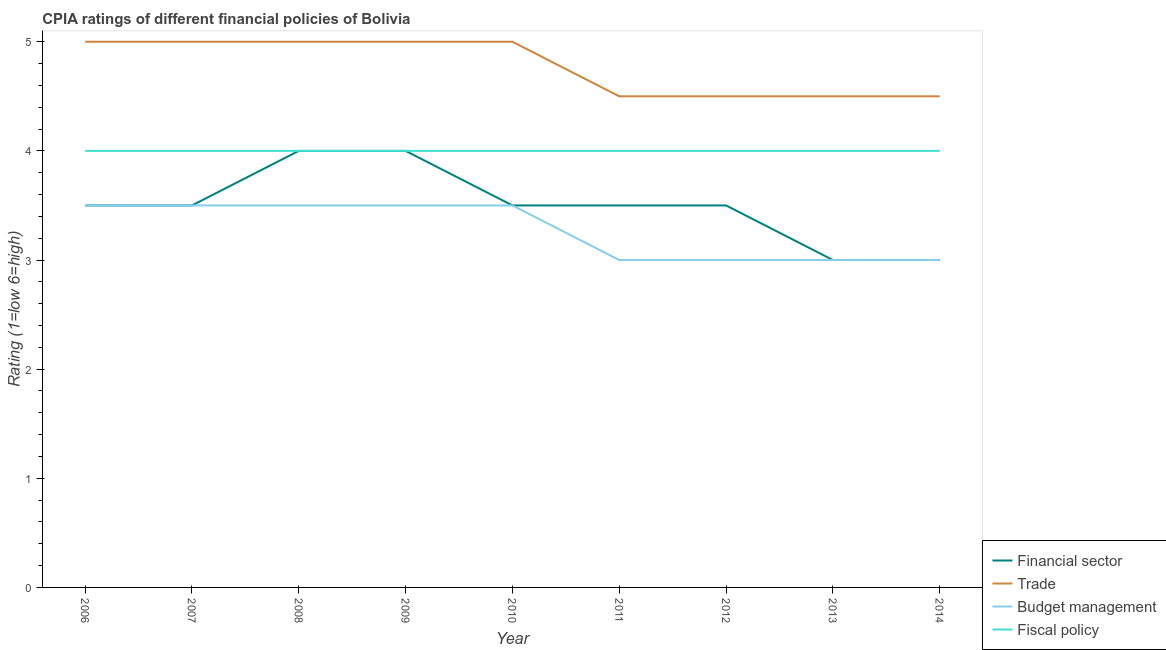How many different coloured lines are there?
Give a very brief answer. 4. Is the number of lines equal to the number of legend labels?
Keep it short and to the point. Yes. What is the cpia rating of fiscal policy in 2011?
Make the answer very short. 4. Across all years, what is the minimum cpia rating of budget management?
Offer a very short reply. 3. In which year was the cpia rating of budget management minimum?
Keep it short and to the point. 2011. What is the total cpia rating of financial sector in the graph?
Give a very brief answer. 31.5. What is the difference between the cpia rating of budget management in 2008 and that in 2011?
Provide a succinct answer. 0.5. What is the average cpia rating of trade per year?
Ensure brevity in your answer.  4.78. What is the ratio of the cpia rating of financial sector in 2008 to that in 2011?
Your answer should be very brief. 1.14. What is the difference between the highest and the second highest cpia rating of financial sector?
Your answer should be very brief. 0. In how many years, is the cpia rating of budget management greater than the average cpia rating of budget management taken over all years?
Keep it short and to the point. 5. Is the sum of the cpia rating of trade in 2007 and 2008 greater than the maximum cpia rating of financial sector across all years?
Provide a succinct answer. Yes. Is it the case that in every year, the sum of the cpia rating of financial sector and cpia rating of trade is greater than the cpia rating of budget management?
Make the answer very short. Yes. How many lines are there?
Give a very brief answer. 4. How many years are there in the graph?
Make the answer very short. 9. How are the legend labels stacked?
Keep it short and to the point. Vertical. What is the title of the graph?
Your response must be concise. CPIA ratings of different financial policies of Bolivia. Does "Secondary" appear as one of the legend labels in the graph?
Keep it short and to the point. No. What is the Rating (1=low 6=high) of Financial sector in 2007?
Provide a succinct answer. 3.5. What is the Rating (1=low 6=high) in Trade in 2007?
Your answer should be very brief. 5. What is the Rating (1=low 6=high) of Budget management in 2007?
Provide a short and direct response. 3.5. What is the Rating (1=low 6=high) in Fiscal policy in 2007?
Your response must be concise. 4. What is the Rating (1=low 6=high) in Budget management in 2008?
Provide a succinct answer. 3.5. What is the Rating (1=low 6=high) of Fiscal policy in 2008?
Keep it short and to the point. 4. What is the Rating (1=low 6=high) in Financial sector in 2009?
Provide a succinct answer. 4. What is the Rating (1=low 6=high) in Trade in 2009?
Keep it short and to the point. 5. What is the Rating (1=low 6=high) in Financial sector in 2010?
Offer a terse response. 3.5. What is the Rating (1=low 6=high) of Fiscal policy in 2010?
Your response must be concise. 4. What is the Rating (1=low 6=high) of Financial sector in 2011?
Your answer should be very brief. 3.5. What is the Rating (1=low 6=high) of Budget management in 2011?
Your answer should be compact. 3. What is the Rating (1=low 6=high) in Financial sector in 2012?
Provide a succinct answer. 3.5. What is the Rating (1=low 6=high) in Financial sector in 2013?
Your response must be concise. 3. What is the Rating (1=low 6=high) of Budget management in 2013?
Provide a succinct answer. 3. What is the Rating (1=low 6=high) of Trade in 2014?
Your response must be concise. 4.5. What is the Rating (1=low 6=high) in Budget management in 2014?
Your answer should be compact. 3. Across all years, what is the maximum Rating (1=low 6=high) of Financial sector?
Offer a very short reply. 4. Across all years, what is the maximum Rating (1=low 6=high) of Fiscal policy?
Your answer should be very brief. 4. Across all years, what is the minimum Rating (1=low 6=high) of Trade?
Your answer should be very brief. 4.5. Across all years, what is the minimum Rating (1=low 6=high) in Fiscal policy?
Make the answer very short. 4. What is the total Rating (1=low 6=high) of Financial sector in the graph?
Offer a terse response. 31.5. What is the total Rating (1=low 6=high) in Trade in the graph?
Your answer should be compact. 43. What is the total Rating (1=low 6=high) of Budget management in the graph?
Your response must be concise. 29.5. What is the total Rating (1=low 6=high) in Fiscal policy in the graph?
Offer a very short reply. 36. What is the difference between the Rating (1=low 6=high) in Financial sector in 2006 and that in 2007?
Keep it short and to the point. 0. What is the difference between the Rating (1=low 6=high) of Trade in 2006 and that in 2007?
Provide a succinct answer. 0. What is the difference between the Rating (1=low 6=high) in Budget management in 2006 and that in 2007?
Keep it short and to the point. 0. What is the difference between the Rating (1=low 6=high) in Fiscal policy in 2006 and that in 2007?
Offer a terse response. 0. What is the difference between the Rating (1=low 6=high) of Fiscal policy in 2006 and that in 2008?
Provide a short and direct response. 0. What is the difference between the Rating (1=low 6=high) of Trade in 2006 and that in 2009?
Offer a very short reply. 0. What is the difference between the Rating (1=low 6=high) of Budget management in 2006 and that in 2010?
Offer a terse response. 0. What is the difference between the Rating (1=low 6=high) in Fiscal policy in 2006 and that in 2010?
Provide a short and direct response. 0. What is the difference between the Rating (1=low 6=high) in Trade in 2006 and that in 2011?
Your answer should be compact. 0.5. What is the difference between the Rating (1=low 6=high) in Budget management in 2006 and that in 2011?
Your response must be concise. 0.5. What is the difference between the Rating (1=low 6=high) of Fiscal policy in 2006 and that in 2011?
Make the answer very short. 0. What is the difference between the Rating (1=low 6=high) of Financial sector in 2006 and that in 2012?
Offer a terse response. 0. What is the difference between the Rating (1=low 6=high) in Fiscal policy in 2006 and that in 2012?
Your response must be concise. 0. What is the difference between the Rating (1=low 6=high) of Financial sector in 2006 and that in 2013?
Ensure brevity in your answer.  0.5. What is the difference between the Rating (1=low 6=high) of Budget management in 2006 and that in 2013?
Offer a terse response. 0.5. What is the difference between the Rating (1=low 6=high) in Fiscal policy in 2006 and that in 2013?
Make the answer very short. 0. What is the difference between the Rating (1=low 6=high) of Financial sector in 2006 and that in 2014?
Your answer should be compact. 0.5. What is the difference between the Rating (1=low 6=high) in Trade in 2006 and that in 2014?
Your response must be concise. 0.5. What is the difference between the Rating (1=low 6=high) of Fiscal policy in 2006 and that in 2014?
Your answer should be compact. 0. What is the difference between the Rating (1=low 6=high) in Fiscal policy in 2007 and that in 2008?
Offer a terse response. 0. What is the difference between the Rating (1=low 6=high) in Financial sector in 2007 and that in 2009?
Offer a very short reply. -0.5. What is the difference between the Rating (1=low 6=high) of Trade in 2007 and that in 2009?
Offer a very short reply. 0. What is the difference between the Rating (1=low 6=high) in Trade in 2007 and that in 2010?
Ensure brevity in your answer.  0. What is the difference between the Rating (1=low 6=high) in Fiscal policy in 2007 and that in 2011?
Your answer should be very brief. 0. What is the difference between the Rating (1=low 6=high) of Trade in 2007 and that in 2012?
Give a very brief answer. 0.5. What is the difference between the Rating (1=low 6=high) of Fiscal policy in 2007 and that in 2012?
Offer a terse response. 0. What is the difference between the Rating (1=low 6=high) of Trade in 2007 and that in 2013?
Keep it short and to the point. 0.5. What is the difference between the Rating (1=low 6=high) of Budget management in 2007 and that in 2013?
Offer a very short reply. 0.5. What is the difference between the Rating (1=low 6=high) in Financial sector in 2007 and that in 2014?
Keep it short and to the point. 0.5. What is the difference between the Rating (1=low 6=high) in Financial sector in 2008 and that in 2009?
Your response must be concise. 0. What is the difference between the Rating (1=low 6=high) of Trade in 2008 and that in 2009?
Give a very brief answer. 0. What is the difference between the Rating (1=low 6=high) in Budget management in 2008 and that in 2009?
Keep it short and to the point. 0. What is the difference between the Rating (1=low 6=high) of Fiscal policy in 2008 and that in 2009?
Offer a terse response. 0. What is the difference between the Rating (1=low 6=high) of Fiscal policy in 2008 and that in 2010?
Keep it short and to the point. 0. What is the difference between the Rating (1=low 6=high) of Financial sector in 2008 and that in 2011?
Make the answer very short. 0.5. What is the difference between the Rating (1=low 6=high) of Budget management in 2008 and that in 2011?
Make the answer very short. 0.5. What is the difference between the Rating (1=low 6=high) of Trade in 2008 and that in 2012?
Give a very brief answer. 0.5. What is the difference between the Rating (1=low 6=high) in Financial sector in 2008 and that in 2013?
Your response must be concise. 1. What is the difference between the Rating (1=low 6=high) of Budget management in 2008 and that in 2013?
Your answer should be very brief. 0.5. What is the difference between the Rating (1=low 6=high) of Fiscal policy in 2008 and that in 2013?
Ensure brevity in your answer.  0. What is the difference between the Rating (1=low 6=high) in Trade in 2008 and that in 2014?
Give a very brief answer. 0.5. What is the difference between the Rating (1=low 6=high) in Budget management in 2008 and that in 2014?
Your response must be concise. 0.5. What is the difference between the Rating (1=low 6=high) in Trade in 2009 and that in 2010?
Keep it short and to the point. 0. What is the difference between the Rating (1=low 6=high) of Budget management in 2009 and that in 2010?
Provide a short and direct response. 0. What is the difference between the Rating (1=low 6=high) in Fiscal policy in 2009 and that in 2010?
Keep it short and to the point. 0. What is the difference between the Rating (1=low 6=high) of Financial sector in 2009 and that in 2011?
Offer a terse response. 0.5. What is the difference between the Rating (1=low 6=high) of Budget management in 2009 and that in 2011?
Make the answer very short. 0.5. What is the difference between the Rating (1=low 6=high) in Fiscal policy in 2009 and that in 2011?
Offer a terse response. 0. What is the difference between the Rating (1=low 6=high) in Trade in 2009 and that in 2012?
Keep it short and to the point. 0.5. What is the difference between the Rating (1=low 6=high) in Budget management in 2009 and that in 2012?
Your answer should be compact. 0.5. What is the difference between the Rating (1=low 6=high) in Financial sector in 2009 and that in 2013?
Your answer should be very brief. 1. What is the difference between the Rating (1=low 6=high) of Trade in 2009 and that in 2013?
Offer a very short reply. 0.5. What is the difference between the Rating (1=low 6=high) of Budget management in 2009 and that in 2013?
Make the answer very short. 0.5. What is the difference between the Rating (1=low 6=high) of Fiscal policy in 2009 and that in 2013?
Keep it short and to the point. 0. What is the difference between the Rating (1=low 6=high) in Financial sector in 2009 and that in 2014?
Provide a succinct answer. 1. What is the difference between the Rating (1=low 6=high) of Budget management in 2009 and that in 2014?
Your answer should be very brief. 0.5. What is the difference between the Rating (1=low 6=high) in Financial sector in 2010 and that in 2011?
Keep it short and to the point. 0. What is the difference between the Rating (1=low 6=high) in Trade in 2010 and that in 2011?
Provide a short and direct response. 0.5. What is the difference between the Rating (1=low 6=high) in Fiscal policy in 2010 and that in 2011?
Your response must be concise. 0. What is the difference between the Rating (1=low 6=high) of Financial sector in 2010 and that in 2012?
Keep it short and to the point. 0. What is the difference between the Rating (1=low 6=high) in Budget management in 2010 and that in 2012?
Your answer should be very brief. 0.5. What is the difference between the Rating (1=low 6=high) in Financial sector in 2010 and that in 2014?
Your answer should be compact. 0.5. What is the difference between the Rating (1=low 6=high) in Budget management in 2010 and that in 2014?
Your answer should be very brief. 0.5. What is the difference between the Rating (1=low 6=high) in Financial sector in 2011 and that in 2013?
Give a very brief answer. 0.5. What is the difference between the Rating (1=low 6=high) in Trade in 2011 and that in 2013?
Offer a very short reply. 0. What is the difference between the Rating (1=low 6=high) of Budget management in 2011 and that in 2013?
Provide a short and direct response. 0. What is the difference between the Rating (1=low 6=high) in Trade in 2011 and that in 2014?
Your answer should be compact. 0. What is the difference between the Rating (1=low 6=high) in Budget management in 2011 and that in 2014?
Provide a succinct answer. 0. What is the difference between the Rating (1=low 6=high) of Financial sector in 2012 and that in 2013?
Your response must be concise. 0.5. What is the difference between the Rating (1=low 6=high) in Trade in 2012 and that in 2013?
Provide a succinct answer. 0. What is the difference between the Rating (1=low 6=high) of Trade in 2012 and that in 2014?
Your answer should be compact. 0. What is the difference between the Rating (1=low 6=high) in Trade in 2013 and that in 2014?
Provide a succinct answer. 0. What is the difference between the Rating (1=low 6=high) of Financial sector in 2006 and the Rating (1=low 6=high) of Trade in 2007?
Give a very brief answer. -1.5. What is the difference between the Rating (1=low 6=high) in Financial sector in 2006 and the Rating (1=low 6=high) in Fiscal policy in 2007?
Give a very brief answer. -0.5. What is the difference between the Rating (1=low 6=high) of Trade in 2006 and the Rating (1=low 6=high) of Budget management in 2007?
Give a very brief answer. 1.5. What is the difference between the Rating (1=low 6=high) in Trade in 2006 and the Rating (1=low 6=high) in Fiscal policy in 2007?
Ensure brevity in your answer.  1. What is the difference between the Rating (1=low 6=high) of Budget management in 2006 and the Rating (1=low 6=high) of Fiscal policy in 2007?
Your response must be concise. -0.5. What is the difference between the Rating (1=low 6=high) in Financial sector in 2006 and the Rating (1=low 6=high) in Budget management in 2008?
Your answer should be compact. 0. What is the difference between the Rating (1=low 6=high) in Trade in 2006 and the Rating (1=low 6=high) in Budget management in 2008?
Offer a very short reply. 1.5. What is the difference between the Rating (1=low 6=high) of Trade in 2006 and the Rating (1=low 6=high) of Fiscal policy in 2008?
Offer a very short reply. 1. What is the difference between the Rating (1=low 6=high) in Financial sector in 2006 and the Rating (1=low 6=high) in Trade in 2009?
Keep it short and to the point. -1.5. What is the difference between the Rating (1=low 6=high) in Trade in 2006 and the Rating (1=low 6=high) in Fiscal policy in 2009?
Make the answer very short. 1. What is the difference between the Rating (1=low 6=high) of Financial sector in 2006 and the Rating (1=low 6=high) of Trade in 2010?
Provide a succinct answer. -1.5. What is the difference between the Rating (1=low 6=high) in Financial sector in 2006 and the Rating (1=low 6=high) in Fiscal policy in 2010?
Offer a very short reply. -0.5. What is the difference between the Rating (1=low 6=high) of Trade in 2006 and the Rating (1=low 6=high) of Budget management in 2010?
Make the answer very short. 1.5. What is the difference between the Rating (1=low 6=high) of Trade in 2006 and the Rating (1=low 6=high) of Fiscal policy in 2010?
Keep it short and to the point. 1. What is the difference between the Rating (1=low 6=high) of Financial sector in 2006 and the Rating (1=low 6=high) of Trade in 2011?
Offer a very short reply. -1. What is the difference between the Rating (1=low 6=high) of Financial sector in 2006 and the Rating (1=low 6=high) of Budget management in 2011?
Your response must be concise. 0.5. What is the difference between the Rating (1=low 6=high) of Financial sector in 2006 and the Rating (1=low 6=high) of Fiscal policy in 2011?
Give a very brief answer. -0.5. What is the difference between the Rating (1=low 6=high) of Trade in 2006 and the Rating (1=low 6=high) of Fiscal policy in 2011?
Your answer should be compact. 1. What is the difference between the Rating (1=low 6=high) of Budget management in 2006 and the Rating (1=low 6=high) of Fiscal policy in 2011?
Offer a very short reply. -0.5. What is the difference between the Rating (1=low 6=high) of Financial sector in 2006 and the Rating (1=low 6=high) of Trade in 2012?
Offer a very short reply. -1. What is the difference between the Rating (1=low 6=high) of Financial sector in 2006 and the Rating (1=low 6=high) of Budget management in 2012?
Your answer should be very brief. 0.5. What is the difference between the Rating (1=low 6=high) of Trade in 2006 and the Rating (1=low 6=high) of Budget management in 2012?
Offer a very short reply. 2. What is the difference between the Rating (1=low 6=high) in Trade in 2006 and the Rating (1=low 6=high) in Fiscal policy in 2012?
Offer a very short reply. 1. What is the difference between the Rating (1=low 6=high) in Budget management in 2006 and the Rating (1=low 6=high) in Fiscal policy in 2012?
Provide a short and direct response. -0.5. What is the difference between the Rating (1=low 6=high) in Financial sector in 2006 and the Rating (1=low 6=high) in Budget management in 2013?
Offer a terse response. 0.5. What is the difference between the Rating (1=low 6=high) of Trade in 2006 and the Rating (1=low 6=high) of Fiscal policy in 2013?
Your answer should be very brief. 1. What is the difference between the Rating (1=low 6=high) in Financial sector in 2006 and the Rating (1=low 6=high) in Fiscal policy in 2014?
Offer a very short reply. -0.5. What is the difference between the Rating (1=low 6=high) of Trade in 2007 and the Rating (1=low 6=high) of Budget management in 2008?
Your response must be concise. 1.5. What is the difference between the Rating (1=low 6=high) of Trade in 2007 and the Rating (1=low 6=high) of Fiscal policy in 2008?
Your answer should be compact. 1. What is the difference between the Rating (1=low 6=high) in Budget management in 2007 and the Rating (1=low 6=high) in Fiscal policy in 2008?
Your answer should be compact. -0.5. What is the difference between the Rating (1=low 6=high) of Financial sector in 2007 and the Rating (1=low 6=high) of Trade in 2009?
Make the answer very short. -1.5. What is the difference between the Rating (1=low 6=high) of Financial sector in 2007 and the Rating (1=low 6=high) of Budget management in 2009?
Provide a short and direct response. 0. What is the difference between the Rating (1=low 6=high) in Trade in 2007 and the Rating (1=low 6=high) in Fiscal policy in 2009?
Offer a terse response. 1. What is the difference between the Rating (1=low 6=high) of Budget management in 2007 and the Rating (1=low 6=high) of Fiscal policy in 2009?
Give a very brief answer. -0.5. What is the difference between the Rating (1=low 6=high) of Financial sector in 2007 and the Rating (1=low 6=high) of Trade in 2010?
Your answer should be very brief. -1.5. What is the difference between the Rating (1=low 6=high) of Financial sector in 2007 and the Rating (1=low 6=high) of Budget management in 2010?
Offer a very short reply. 0. What is the difference between the Rating (1=low 6=high) of Financial sector in 2007 and the Rating (1=low 6=high) of Fiscal policy in 2010?
Offer a terse response. -0.5. What is the difference between the Rating (1=low 6=high) in Trade in 2007 and the Rating (1=low 6=high) in Fiscal policy in 2010?
Provide a succinct answer. 1. What is the difference between the Rating (1=low 6=high) of Budget management in 2007 and the Rating (1=low 6=high) of Fiscal policy in 2010?
Keep it short and to the point. -0.5. What is the difference between the Rating (1=low 6=high) in Financial sector in 2007 and the Rating (1=low 6=high) in Trade in 2011?
Your response must be concise. -1. What is the difference between the Rating (1=low 6=high) of Financial sector in 2007 and the Rating (1=low 6=high) of Budget management in 2011?
Keep it short and to the point. 0.5. What is the difference between the Rating (1=low 6=high) of Financial sector in 2007 and the Rating (1=low 6=high) of Fiscal policy in 2011?
Your answer should be compact. -0.5. What is the difference between the Rating (1=low 6=high) of Trade in 2007 and the Rating (1=low 6=high) of Fiscal policy in 2011?
Keep it short and to the point. 1. What is the difference between the Rating (1=low 6=high) in Financial sector in 2007 and the Rating (1=low 6=high) in Trade in 2012?
Your response must be concise. -1. What is the difference between the Rating (1=low 6=high) of Financial sector in 2007 and the Rating (1=low 6=high) of Budget management in 2012?
Ensure brevity in your answer.  0.5. What is the difference between the Rating (1=low 6=high) in Financial sector in 2007 and the Rating (1=low 6=high) in Fiscal policy in 2012?
Your answer should be very brief. -0.5. What is the difference between the Rating (1=low 6=high) of Trade in 2007 and the Rating (1=low 6=high) of Fiscal policy in 2012?
Give a very brief answer. 1. What is the difference between the Rating (1=low 6=high) in Budget management in 2007 and the Rating (1=low 6=high) in Fiscal policy in 2012?
Keep it short and to the point. -0.5. What is the difference between the Rating (1=low 6=high) in Financial sector in 2007 and the Rating (1=low 6=high) in Budget management in 2013?
Offer a very short reply. 0.5. What is the difference between the Rating (1=low 6=high) in Financial sector in 2007 and the Rating (1=low 6=high) in Fiscal policy in 2013?
Ensure brevity in your answer.  -0.5. What is the difference between the Rating (1=low 6=high) in Trade in 2007 and the Rating (1=low 6=high) in Budget management in 2013?
Offer a very short reply. 2. What is the difference between the Rating (1=low 6=high) of Trade in 2007 and the Rating (1=low 6=high) of Fiscal policy in 2013?
Provide a short and direct response. 1. What is the difference between the Rating (1=low 6=high) in Financial sector in 2007 and the Rating (1=low 6=high) in Fiscal policy in 2014?
Ensure brevity in your answer.  -0.5. What is the difference between the Rating (1=low 6=high) of Financial sector in 2008 and the Rating (1=low 6=high) of Trade in 2009?
Your answer should be compact. -1. What is the difference between the Rating (1=low 6=high) in Financial sector in 2008 and the Rating (1=low 6=high) in Fiscal policy in 2009?
Make the answer very short. 0. What is the difference between the Rating (1=low 6=high) of Trade in 2008 and the Rating (1=low 6=high) of Fiscal policy in 2009?
Your response must be concise. 1. What is the difference between the Rating (1=low 6=high) of Budget management in 2008 and the Rating (1=low 6=high) of Fiscal policy in 2009?
Provide a succinct answer. -0.5. What is the difference between the Rating (1=low 6=high) of Financial sector in 2008 and the Rating (1=low 6=high) of Budget management in 2010?
Give a very brief answer. 0.5. What is the difference between the Rating (1=low 6=high) of Trade in 2008 and the Rating (1=low 6=high) of Budget management in 2010?
Ensure brevity in your answer.  1.5. What is the difference between the Rating (1=low 6=high) of Budget management in 2008 and the Rating (1=low 6=high) of Fiscal policy in 2010?
Your answer should be very brief. -0.5. What is the difference between the Rating (1=low 6=high) in Trade in 2008 and the Rating (1=low 6=high) in Budget management in 2011?
Give a very brief answer. 2. What is the difference between the Rating (1=low 6=high) of Budget management in 2008 and the Rating (1=low 6=high) of Fiscal policy in 2011?
Offer a terse response. -0.5. What is the difference between the Rating (1=low 6=high) in Financial sector in 2008 and the Rating (1=low 6=high) in Trade in 2012?
Your response must be concise. -0.5. What is the difference between the Rating (1=low 6=high) in Financial sector in 2008 and the Rating (1=low 6=high) in Trade in 2013?
Provide a short and direct response. -0.5. What is the difference between the Rating (1=low 6=high) of Financial sector in 2008 and the Rating (1=low 6=high) of Fiscal policy in 2013?
Provide a succinct answer. 0. What is the difference between the Rating (1=low 6=high) of Trade in 2008 and the Rating (1=low 6=high) of Budget management in 2013?
Your answer should be compact. 2. What is the difference between the Rating (1=low 6=high) of Budget management in 2008 and the Rating (1=low 6=high) of Fiscal policy in 2013?
Ensure brevity in your answer.  -0.5. What is the difference between the Rating (1=low 6=high) in Financial sector in 2008 and the Rating (1=low 6=high) in Budget management in 2014?
Offer a very short reply. 1. What is the difference between the Rating (1=low 6=high) in Budget management in 2008 and the Rating (1=low 6=high) in Fiscal policy in 2014?
Offer a very short reply. -0.5. What is the difference between the Rating (1=low 6=high) of Financial sector in 2009 and the Rating (1=low 6=high) of Trade in 2010?
Offer a terse response. -1. What is the difference between the Rating (1=low 6=high) in Trade in 2009 and the Rating (1=low 6=high) in Budget management in 2010?
Your answer should be very brief. 1.5. What is the difference between the Rating (1=low 6=high) in Trade in 2009 and the Rating (1=low 6=high) in Fiscal policy in 2010?
Your answer should be compact. 1. What is the difference between the Rating (1=low 6=high) in Budget management in 2009 and the Rating (1=low 6=high) in Fiscal policy in 2010?
Provide a short and direct response. -0.5. What is the difference between the Rating (1=low 6=high) of Financial sector in 2009 and the Rating (1=low 6=high) of Budget management in 2011?
Your answer should be very brief. 1. What is the difference between the Rating (1=low 6=high) of Financial sector in 2009 and the Rating (1=low 6=high) of Fiscal policy in 2011?
Provide a short and direct response. 0. What is the difference between the Rating (1=low 6=high) of Financial sector in 2009 and the Rating (1=low 6=high) of Trade in 2012?
Offer a very short reply. -0.5. What is the difference between the Rating (1=low 6=high) in Trade in 2009 and the Rating (1=low 6=high) in Fiscal policy in 2012?
Provide a short and direct response. 1. What is the difference between the Rating (1=low 6=high) of Financial sector in 2009 and the Rating (1=low 6=high) of Fiscal policy in 2013?
Your answer should be very brief. 0. What is the difference between the Rating (1=low 6=high) of Trade in 2009 and the Rating (1=low 6=high) of Budget management in 2013?
Keep it short and to the point. 2. What is the difference between the Rating (1=low 6=high) in Financial sector in 2009 and the Rating (1=low 6=high) in Trade in 2014?
Keep it short and to the point. -0.5. What is the difference between the Rating (1=low 6=high) of Financial sector in 2009 and the Rating (1=low 6=high) of Budget management in 2014?
Provide a succinct answer. 1. What is the difference between the Rating (1=low 6=high) in Financial sector in 2009 and the Rating (1=low 6=high) in Fiscal policy in 2014?
Provide a short and direct response. 0. What is the difference between the Rating (1=low 6=high) of Trade in 2009 and the Rating (1=low 6=high) of Budget management in 2014?
Offer a terse response. 2. What is the difference between the Rating (1=low 6=high) of Trade in 2009 and the Rating (1=low 6=high) of Fiscal policy in 2014?
Give a very brief answer. 1. What is the difference between the Rating (1=low 6=high) in Financial sector in 2010 and the Rating (1=low 6=high) in Trade in 2011?
Offer a very short reply. -1. What is the difference between the Rating (1=low 6=high) in Financial sector in 2010 and the Rating (1=low 6=high) in Budget management in 2011?
Your answer should be compact. 0.5. What is the difference between the Rating (1=low 6=high) in Financial sector in 2010 and the Rating (1=low 6=high) in Fiscal policy in 2011?
Your response must be concise. -0.5. What is the difference between the Rating (1=low 6=high) in Trade in 2010 and the Rating (1=low 6=high) in Budget management in 2011?
Your answer should be compact. 2. What is the difference between the Rating (1=low 6=high) in Trade in 2010 and the Rating (1=low 6=high) in Fiscal policy in 2011?
Make the answer very short. 1. What is the difference between the Rating (1=low 6=high) in Budget management in 2010 and the Rating (1=low 6=high) in Fiscal policy in 2011?
Make the answer very short. -0.5. What is the difference between the Rating (1=low 6=high) of Trade in 2010 and the Rating (1=low 6=high) of Fiscal policy in 2012?
Your answer should be compact. 1. What is the difference between the Rating (1=low 6=high) of Budget management in 2010 and the Rating (1=low 6=high) of Fiscal policy in 2012?
Your answer should be compact. -0.5. What is the difference between the Rating (1=low 6=high) in Trade in 2010 and the Rating (1=low 6=high) in Budget management in 2013?
Your response must be concise. 2. What is the difference between the Rating (1=low 6=high) in Trade in 2010 and the Rating (1=low 6=high) in Fiscal policy in 2013?
Your answer should be compact. 1. What is the difference between the Rating (1=low 6=high) of Budget management in 2010 and the Rating (1=low 6=high) of Fiscal policy in 2013?
Provide a succinct answer. -0.5. What is the difference between the Rating (1=low 6=high) of Budget management in 2010 and the Rating (1=low 6=high) of Fiscal policy in 2014?
Make the answer very short. -0.5. What is the difference between the Rating (1=low 6=high) in Financial sector in 2011 and the Rating (1=low 6=high) in Trade in 2012?
Your answer should be compact. -1. What is the difference between the Rating (1=low 6=high) in Trade in 2011 and the Rating (1=low 6=high) in Budget management in 2012?
Provide a short and direct response. 1.5. What is the difference between the Rating (1=low 6=high) of Trade in 2011 and the Rating (1=low 6=high) of Budget management in 2013?
Give a very brief answer. 1.5. What is the difference between the Rating (1=low 6=high) in Trade in 2011 and the Rating (1=low 6=high) in Fiscal policy in 2013?
Make the answer very short. 0.5. What is the difference between the Rating (1=low 6=high) in Financial sector in 2011 and the Rating (1=low 6=high) in Trade in 2014?
Your answer should be very brief. -1. What is the difference between the Rating (1=low 6=high) of Financial sector in 2011 and the Rating (1=low 6=high) of Budget management in 2014?
Make the answer very short. 0.5. What is the difference between the Rating (1=low 6=high) of Financial sector in 2011 and the Rating (1=low 6=high) of Fiscal policy in 2014?
Your answer should be compact. -0.5. What is the difference between the Rating (1=low 6=high) of Trade in 2011 and the Rating (1=low 6=high) of Fiscal policy in 2014?
Keep it short and to the point. 0.5. What is the difference between the Rating (1=low 6=high) in Financial sector in 2012 and the Rating (1=low 6=high) in Budget management in 2013?
Provide a succinct answer. 0.5. What is the difference between the Rating (1=low 6=high) of Financial sector in 2012 and the Rating (1=low 6=high) of Trade in 2014?
Your response must be concise. -1. What is the difference between the Rating (1=low 6=high) in Financial sector in 2012 and the Rating (1=low 6=high) in Fiscal policy in 2014?
Make the answer very short. -0.5. What is the difference between the Rating (1=low 6=high) of Financial sector in 2013 and the Rating (1=low 6=high) of Budget management in 2014?
Provide a succinct answer. 0. What is the difference between the Rating (1=low 6=high) in Financial sector in 2013 and the Rating (1=low 6=high) in Fiscal policy in 2014?
Your response must be concise. -1. What is the difference between the Rating (1=low 6=high) of Trade in 2013 and the Rating (1=low 6=high) of Budget management in 2014?
Provide a succinct answer. 1.5. What is the difference between the Rating (1=low 6=high) in Trade in 2013 and the Rating (1=low 6=high) in Fiscal policy in 2014?
Make the answer very short. 0.5. What is the difference between the Rating (1=low 6=high) in Budget management in 2013 and the Rating (1=low 6=high) in Fiscal policy in 2014?
Make the answer very short. -1. What is the average Rating (1=low 6=high) in Financial sector per year?
Your response must be concise. 3.5. What is the average Rating (1=low 6=high) of Trade per year?
Your response must be concise. 4.78. What is the average Rating (1=low 6=high) of Budget management per year?
Your answer should be compact. 3.28. In the year 2006, what is the difference between the Rating (1=low 6=high) in Financial sector and Rating (1=low 6=high) in Budget management?
Provide a succinct answer. 0. In the year 2006, what is the difference between the Rating (1=low 6=high) of Trade and Rating (1=low 6=high) of Budget management?
Your answer should be compact. 1.5. In the year 2006, what is the difference between the Rating (1=low 6=high) in Budget management and Rating (1=low 6=high) in Fiscal policy?
Keep it short and to the point. -0.5. In the year 2007, what is the difference between the Rating (1=low 6=high) of Financial sector and Rating (1=low 6=high) of Budget management?
Provide a succinct answer. 0. In the year 2007, what is the difference between the Rating (1=low 6=high) in Trade and Rating (1=low 6=high) in Budget management?
Offer a very short reply. 1.5. In the year 2007, what is the difference between the Rating (1=low 6=high) of Budget management and Rating (1=low 6=high) of Fiscal policy?
Provide a succinct answer. -0.5. In the year 2008, what is the difference between the Rating (1=low 6=high) of Financial sector and Rating (1=low 6=high) of Trade?
Offer a terse response. -1. In the year 2008, what is the difference between the Rating (1=low 6=high) of Trade and Rating (1=low 6=high) of Budget management?
Your answer should be compact. 1.5. In the year 2008, what is the difference between the Rating (1=low 6=high) of Trade and Rating (1=low 6=high) of Fiscal policy?
Offer a very short reply. 1. In the year 2008, what is the difference between the Rating (1=low 6=high) in Budget management and Rating (1=low 6=high) in Fiscal policy?
Keep it short and to the point. -0.5. In the year 2009, what is the difference between the Rating (1=low 6=high) of Financial sector and Rating (1=low 6=high) of Budget management?
Keep it short and to the point. 0.5. In the year 2009, what is the difference between the Rating (1=low 6=high) of Financial sector and Rating (1=low 6=high) of Fiscal policy?
Provide a succinct answer. 0. In the year 2009, what is the difference between the Rating (1=low 6=high) in Trade and Rating (1=low 6=high) in Fiscal policy?
Offer a very short reply. 1. In the year 2009, what is the difference between the Rating (1=low 6=high) of Budget management and Rating (1=low 6=high) of Fiscal policy?
Offer a terse response. -0.5. In the year 2010, what is the difference between the Rating (1=low 6=high) in Trade and Rating (1=low 6=high) in Budget management?
Your answer should be compact. 1.5. In the year 2011, what is the difference between the Rating (1=low 6=high) of Financial sector and Rating (1=low 6=high) of Fiscal policy?
Ensure brevity in your answer.  -0.5. In the year 2011, what is the difference between the Rating (1=low 6=high) of Budget management and Rating (1=low 6=high) of Fiscal policy?
Offer a terse response. -1. In the year 2012, what is the difference between the Rating (1=low 6=high) of Financial sector and Rating (1=low 6=high) of Fiscal policy?
Offer a terse response. -0.5. In the year 2012, what is the difference between the Rating (1=low 6=high) in Budget management and Rating (1=low 6=high) in Fiscal policy?
Offer a terse response. -1. In the year 2013, what is the difference between the Rating (1=low 6=high) in Financial sector and Rating (1=low 6=high) in Budget management?
Provide a short and direct response. 0. In the year 2013, what is the difference between the Rating (1=low 6=high) in Financial sector and Rating (1=low 6=high) in Fiscal policy?
Make the answer very short. -1. In the year 2013, what is the difference between the Rating (1=low 6=high) of Trade and Rating (1=low 6=high) of Budget management?
Make the answer very short. 1.5. In the year 2013, what is the difference between the Rating (1=low 6=high) of Budget management and Rating (1=low 6=high) of Fiscal policy?
Your answer should be compact. -1. In the year 2014, what is the difference between the Rating (1=low 6=high) in Financial sector and Rating (1=low 6=high) in Trade?
Offer a terse response. -1.5. In the year 2014, what is the difference between the Rating (1=low 6=high) in Financial sector and Rating (1=low 6=high) in Budget management?
Provide a short and direct response. 0. In the year 2014, what is the difference between the Rating (1=low 6=high) in Trade and Rating (1=low 6=high) in Fiscal policy?
Make the answer very short. 0.5. In the year 2014, what is the difference between the Rating (1=low 6=high) of Budget management and Rating (1=low 6=high) of Fiscal policy?
Your answer should be compact. -1. What is the ratio of the Rating (1=low 6=high) of Financial sector in 2006 to that in 2007?
Provide a short and direct response. 1. What is the ratio of the Rating (1=low 6=high) in Fiscal policy in 2006 to that in 2007?
Offer a very short reply. 1. What is the ratio of the Rating (1=low 6=high) of Budget management in 2006 to that in 2008?
Provide a short and direct response. 1. What is the ratio of the Rating (1=low 6=high) in Financial sector in 2006 to that in 2009?
Your response must be concise. 0.88. What is the ratio of the Rating (1=low 6=high) of Trade in 2006 to that in 2009?
Provide a succinct answer. 1. What is the ratio of the Rating (1=low 6=high) in Budget management in 2006 to that in 2009?
Make the answer very short. 1. What is the ratio of the Rating (1=low 6=high) of Fiscal policy in 2006 to that in 2009?
Offer a very short reply. 1. What is the ratio of the Rating (1=low 6=high) of Financial sector in 2006 to that in 2010?
Your answer should be compact. 1. What is the ratio of the Rating (1=low 6=high) in Trade in 2006 to that in 2010?
Make the answer very short. 1. What is the ratio of the Rating (1=low 6=high) of Budget management in 2006 to that in 2010?
Your answer should be compact. 1. What is the ratio of the Rating (1=low 6=high) in Budget management in 2006 to that in 2011?
Offer a very short reply. 1.17. What is the ratio of the Rating (1=low 6=high) of Financial sector in 2006 to that in 2012?
Offer a very short reply. 1. What is the ratio of the Rating (1=low 6=high) in Budget management in 2006 to that in 2012?
Offer a terse response. 1.17. What is the ratio of the Rating (1=low 6=high) in Fiscal policy in 2006 to that in 2012?
Provide a short and direct response. 1. What is the ratio of the Rating (1=low 6=high) of Financial sector in 2006 to that in 2013?
Your answer should be compact. 1.17. What is the ratio of the Rating (1=low 6=high) in Fiscal policy in 2006 to that in 2013?
Your response must be concise. 1. What is the ratio of the Rating (1=low 6=high) of Financial sector in 2006 to that in 2014?
Offer a very short reply. 1.17. What is the ratio of the Rating (1=low 6=high) of Trade in 2006 to that in 2014?
Offer a very short reply. 1.11. What is the ratio of the Rating (1=low 6=high) of Fiscal policy in 2006 to that in 2014?
Keep it short and to the point. 1. What is the ratio of the Rating (1=low 6=high) of Financial sector in 2007 to that in 2008?
Keep it short and to the point. 0.88. What is the ratio of the Rating (1=low 6=high) of Trade in 2007 to that in 2008?
Offer a terse response. 1. What is the ratio of the Rating (1=low 6=high) of Budget management in 2007 to that in 2008?
Provide a succinct answer. 1. What is the ratio of the Rating (1=low 6=high) of Trade in 2007 to that in 2009?
Make the answer very short. 1. What is the ratio of the Rating (1=low 6=high) in Budget management in 2007 to that in 2009?
Provide a short and direct response. 1. What is the ratio of the Rating (1=low 6=high) of Fiscal policy in 2007 to that in 2009?
Make the answer very short. 1. What is the ratio of the Rating (1=low 6=high) of Budget management in 2007 to that in 2010?
Give a very brief answer. 1. What is the ratio of the Rating (1=low 6=high) in Fiscal policy in 2007 to that in 2010?
Your answer should be compact. 1. What is the ratio of the Rating (1=low 6=high) in Trade in 2007 to that in 2011?
Offer a very short reply. 1.11. What is the ratio of the Rating (1=low 6=high) of Fiscal policy in 2007 to that in 2011?
Provide a short and direct response. 1. What is the ratio of the Rating (1=low 6=high) of Trade in 2007 to that in 2012?
Make the answer very short. 1.11. What is the ratio of the Rating (1=low 6=high) of Budget management in 2007 to that in 2012?
Provide a succinct answer. 1.17. What is the ratio of the Rating (1=low 6=high) of Fiscal policy in 2007 to that in 2012?
Your answer should be very brief. 1. What is the ratio of the Rating (1=low 6=high) in Trade in 2007 to that in 2013?
Your answer should be very brief. 1.11. What is the ratio of the Rating (1=low 6=high) in Budget management in 2007 to that in 2013?
Provide a short and direct response. 1.17. What is the ratio of the Rating (1=low 6=high) in Fiscal policy in 2007 to that in 2013?
Your answer should be very brief. 1. What is the ratio of the Rating (1=low 6=high) in Financial sector in 2007 to that in 2014?
Your answer should be very brief. 1.17. What is the ratio of the Rating (1=low 6=high) in Trade in 2007 to that in 2014?
Make the answer very short. 1.11. What is the ratio of the Rating (1=low 6=high) of Budget management in 2007 to that in 2014?
Give a very brief answer. 1.17. What is the ratio of the Rating (1=low 6=high) of Fiscal policy in 2007 to that in 2014?
Your answer should be very brief. 1. What is the ratio of the Rating (1=low 6=high) in Financial sector in 2008 to that in 2009?
Your answer should be very brief. 1. What is the ratio of the Rating (1=low 6=high) of Trade in 2008 to that in 2009?
Your answer should be compact. 1. What is the ratio of the Rating (1=low 6=high) in Fiscal policy in 2008 to that in 2009?
Provide a succinct answer. 1. What is the ratio of the Rating (1=low 6=high) of Budget management in 2008 to that in 2010?
Your answer should be very brief. 1. What is the ratio of the Rating (1=low 6=high) in Financial sector in 2008 to that in 2011?
Your answer should be compact. 1.14. What is the ratio of the Rating (1=low 6=high) in Trade in 2008 to that in 2011?
Make the answer very short. 1.11. What is the ratio of the Rating (1=low 6=high) of Trade in 2008 to that in 2012?
Offer a terse response. 1.11. What is the ratio of the Rating (1=low 6=high) of Fiscal policy in 2008 to that in 2012?
Your answer should be compact. 1. What is the ratio of the Rating (1=low 6=high) of Financial sector in 2008 to that in 2013?
Provide a short and direct response. 1.33. What is the ratio of the Rating (1=low 6=high) in Trade in 2008 to that in 2013?
Your response must be concise. 1.11. What is the ratio of the Rating (1=low 6=high) of Budget management in 2008 to that in 2013?
Offer a very short reply. 1.17. What is the ratio of the Rating (1=low 6=high) of Budget management in 2008 to that in 2014?
Ensure brevity in your answer.  1.17. What is the ratio of the Rating (1=low 6=high) of Fiscal policy in 2008 to that in 2014?
Provide a short and direct response. 1. What is the ratio of the Rating (1=low 6=high) of Trade in 2009 to that in 2010?
Your answer should be very brief. 1. What is the ratio of the Rating (1=low 6=high) of Budget management in 2009 to that in 2010?
Ensure brevity in your answer.  1. What is the ratio of the Rating (1=low 6=high) in Fiscal policy in 2009 to that in 2010?
Your response must be concise. 1. What is the ratio of the Rating (1=low 6=high) of Financial sector in 2009 to that in 2011?
Provide a succinct answer. 1.14. What is the ratio of the Rating (1=low 6=high) of Trade in 2009 to that in 2011?
Offer a terse response. 1.11. What is the ratio of the Rating (1=low 6=high) of Fiscal policy in 2009 to that in 2011?
Give a very brief answer. 1. What is the ratio of the Rating (1=low 6=high) in Budget management in 2009 to that in 2013?
Give a very brief answer. 1.17. What is the ratio of the Rating (1=low 6=high) of Financial sector in 2009 to that in 2014?
Provide a succinct answer. 1.33. What is the ratio of the Rating (1=low 6=high) of Fiscal policy in 2009 to that in 2014?
Provide a short and direct response. 1. What is the ratio of the Rating (1=low 6=high) in Financial sector in 2010 to that in 2011?
Provide a short and direct response. 1. What is the ratio of the Rating (1=low 6=high) of Budget management in 2010 to that in 2011?
Ensure brevity in your answer.  1.17. What is the ratio of the Rating (1=low 6=high) in Trade in 2010 to that in 2012?
Your answer should be very brief. 1.11. What is the ratio of the Rating (1=low 6=high) of Fiscal policy in 2010 to that in 2012?
Keep it short and to the point. 1. What is the ratio of the Rating (1=low 6=high) of Fiscal policy in 2010 to that in 2013?
Keep it short and to the point. 1. What is the ratio of the Rating (1=low 6=high) of Financial sector in 2010 to that in 2014?
Keep it short and to the point. 1.17. What is the ratio of the Rating (1=low 6=high) of Trade in 2010 to that in 2014?
Offer a very short reply. 1.11. What is the ratio of the Rating (1=low 6=high) of Fiscal policy in 2010 to that in 2014?
Provide a short and direct response. 1. What is the ratio of the Rating (1=low 6=high) of Financial sector in 2011 to that in 2012?
Keep it short and to the point. 1. What is the ratio of the Rating (1=low 6=high) of Fiscal policy in 2011 to that in 2012?
Keep it short and to the point. 1. What is the ratio of the Rating (1=low 6=high) of Financial sector in 2011 to that in 2013?
Keep it short and to the point. 1.17. What is the ratio of the Rating (1=low 6=high) in Trade in 2011 to that in 2013?
Your answer should be compact. 1. What is the ratio of the Rating (1=low 6=high) in Budget management in 2011 to that in 2013?
Offer a very short reply. 1. What is the ratio of the Rating (1=low 6=high) of Fiscal policy in 2011 to that in 2013?
Provide a short and direct response. 1. What is the ratio of the Rating (1=low 6=high) in Trade in 2011 to that in 2014?
Provide a short and direct response. 1. What is the ratio of the Rating (1=low 6=high) of Budget management in 2011 to that in 2014?
Provide a short and direct response. 1. What is the ratio of the Rating (1=low 6=high) of Fiscal policy in 2011 to that in 2014?
Your answer should be very brief. 1. What is the ratio of the Rating (1=low 6=high) in Financial sector in 2012 to that in 2013?
Keep it short and to the point. 1.17. What is the ratio of the Rating (1=low 6=high) of Budget management in 2013 to that in 2014?
Ensure brevity in your answer.  1. What is the difference between the highest and the second highest Rating (1=low 6=high) in Trade?
Your answer should be compact. 0. What is the difference between the highest and the second highest Rating (1=low 6=high) in Fiscal policy?
Give a very brief answer. 0. What is the difference between the highest and the lowest Rating (1=low 6=high) of Financial sector?
Provide a short and direct response. 1. What is the difference between the highest and the lowest Rating (1=low 6=high) in Trade?
Your answer should be very brief. 0.5. What is the difference between the highest and the lowest Rating (1=low 6=high) in Budget management?
Your response must be concise. 0.5. 